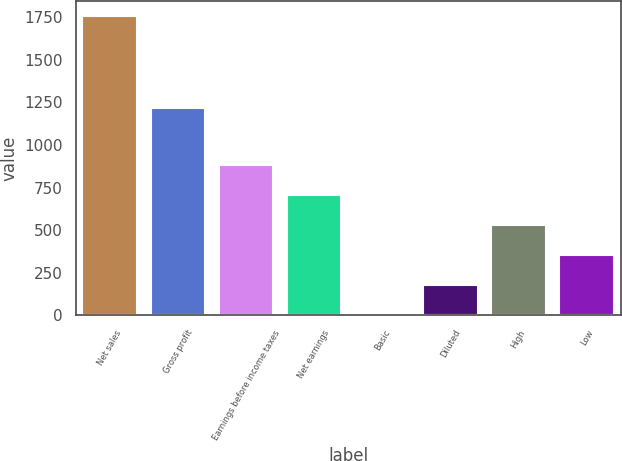<chart> <loc_0><loc_0><loc_500><loc_500><bar_chart><fcel>Net sales<fcel>Gross profit<fcel>Earnings before income taxes<fcel>Net earnings<fcel>Basic<fcel>Diluted<fcel>High<fcel>Low<nl><fcel>1758.2<fcel>1218.9<fcel>879.5<fcel>703.76<fcel>0.8<fcel>176.54<fcel>528.02<fcel>352.28<nl></chart> 